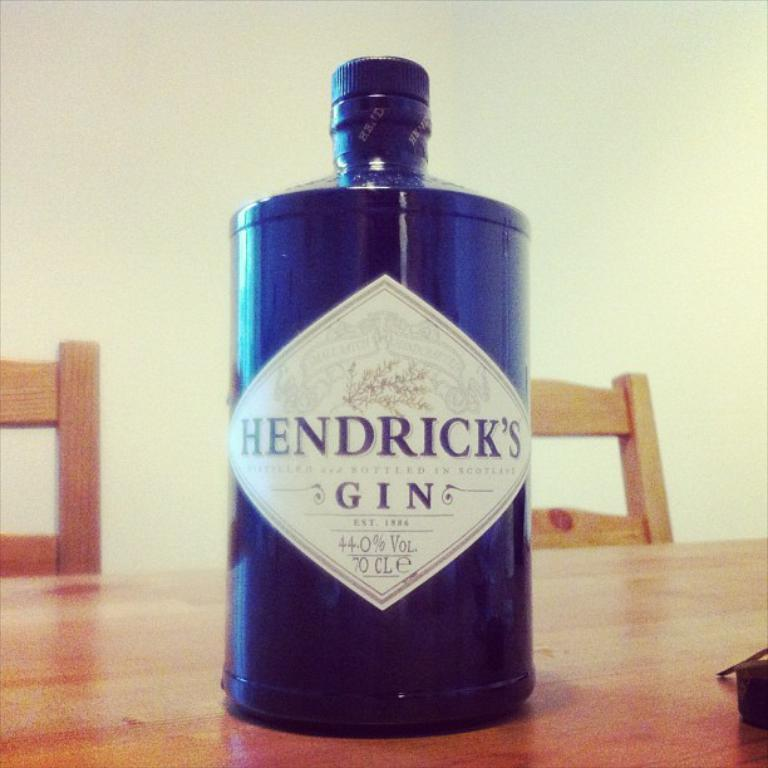<image>
Give a short and clear explanation of the subsequent image. A blue bottle of Hendrick's Gin is on a table. 